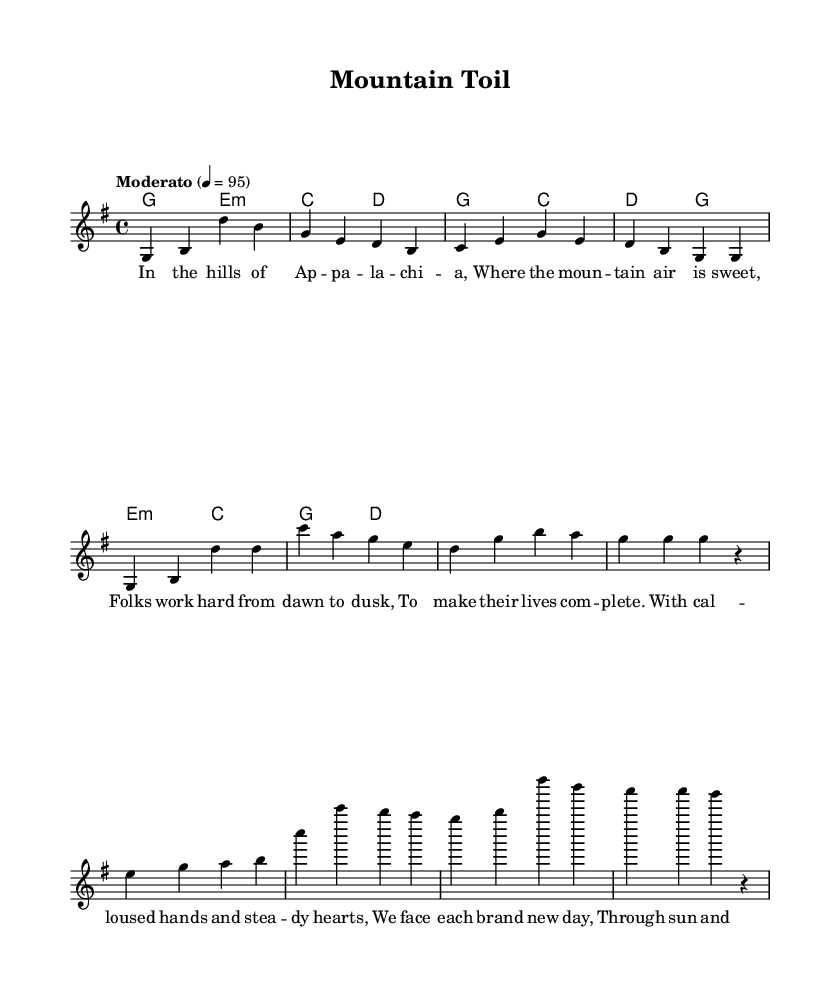What is the key signature of this music? The key signature is indicated at the beginning of the score, where it shows one sharp, meaning the piece is in G major.
Answer: G major What is the time signature of this music? The time signature is found right after the key signature, showing a "4/4" mark indicating there are four beats in a measure and the quarter note gets one beat.
Answer: 4/4 What is the tempo marking for this piece? The tempo marking is written below the time signature, stating "Moderato" and the tempo of 95 beats per minute, which guides the speed of the piece.
Answer: Moderato How many verses are present in the music? By analyzing the structure, we see the lyrics section contains "Verse" lyrics that are followed by "Chorus" and "Bridge," indicating there is one verse present.
Answer: One What is the primary theme of the lyrics? Looking at the lyrics' content, the themes revolve around hard work, perseverance, and the beauty of life in the Appalachian region, which forms the essence of traditional folk ballads.
Answer: Perseverance How many chords are used in the verse section? The harmonic section shows two chords are used in the verse part, specifically "g2 e:m" and "c2 d," counting them reveals there are two distinct chords.
Answer: Two What emotion do the lyrics convey regarding challenges? Analyzing the bridge lyrics reveals that they speak of facing tough times with determination and resilience, emphasizing the grit to never surrender.
Answer: Resilience 